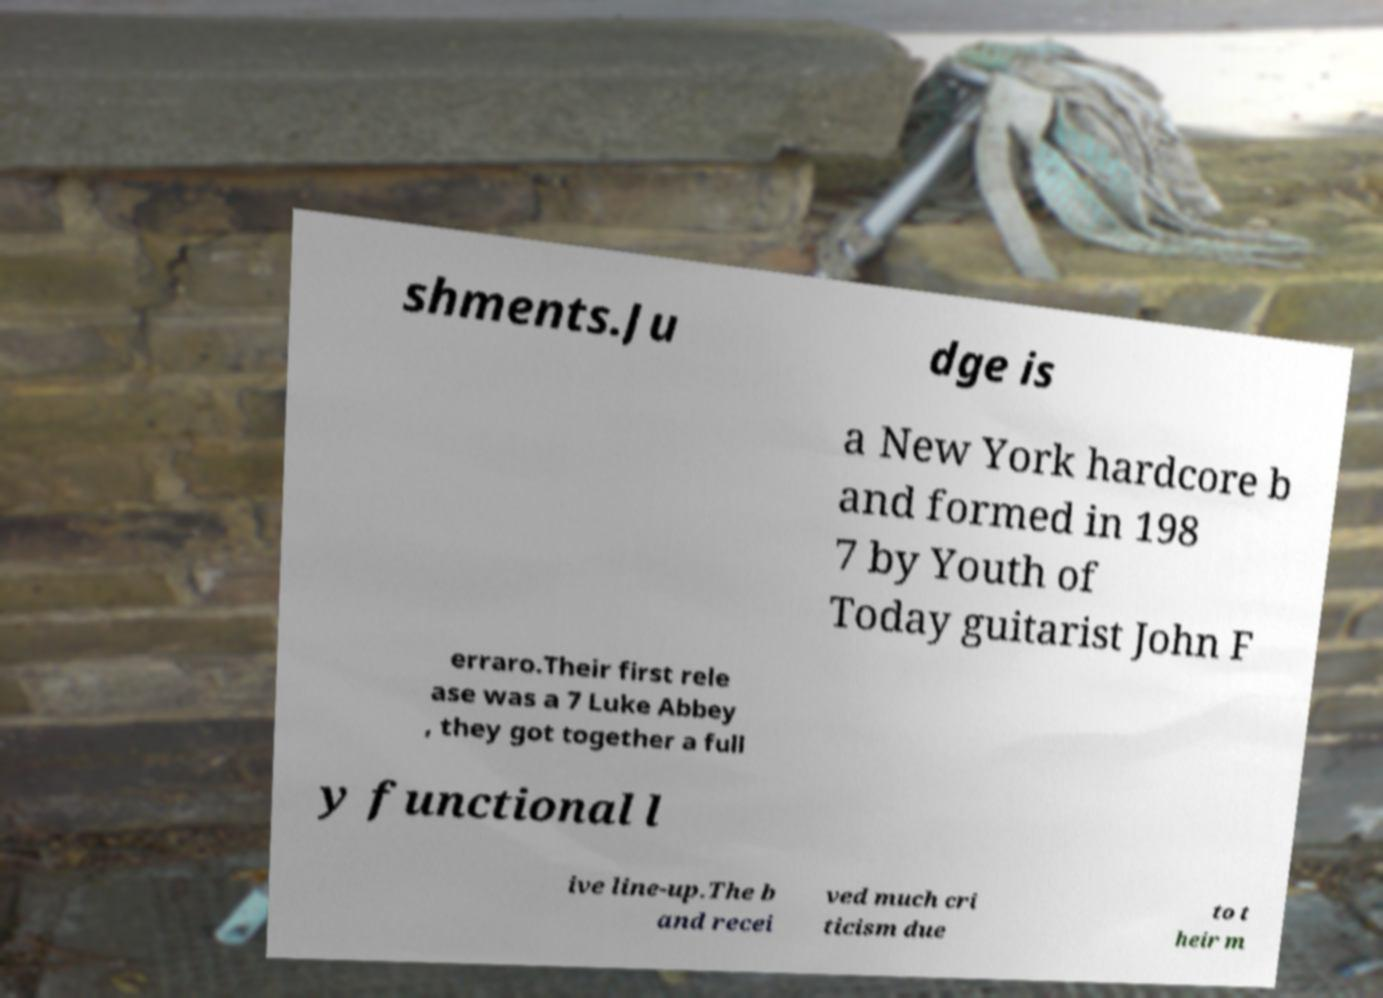For documentation purposes, I need the text within this image transcribed. Could you provide that? shments.Ju dge is a New York hardcore b and formed in 198 7 by Youth of Today guitarist John F erraro.Their first rele ase was a 7 Luke Abbey , they got together a full y functional l ive line-up.The b and recei ved much cri ticism due to t heir m 